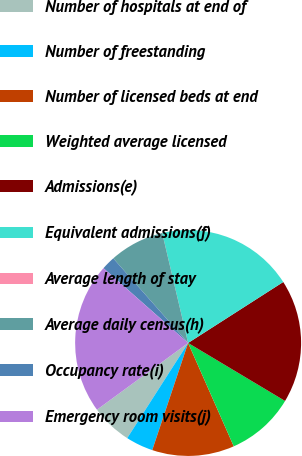Convert chart to OTSL. <chart><loc_0><loc_0><loc_500><loc_500><pie_chart><fcel>Number of hospitals at end of<fcel>Number of freestanding<fcel>Number of licensed beds at end<fcel>Weighted average licensed<fcel>Admissions(e)<fcel>Equivalent admissions(f)<fcel>Average length of stay<fcel>Average daily census(h)<fcel>Occupancy rate(i)<fcel>Emergency room visits(j)<nl><fcel>5.88%<fcel>3.92%<fcel>11.76%<fcel>9.8%<fcel>17.65%<fcel>19.61%<fcel>0.0%<fcel>7.84%<fcel>1.96%<fcel>21.57%<nl></chart> 